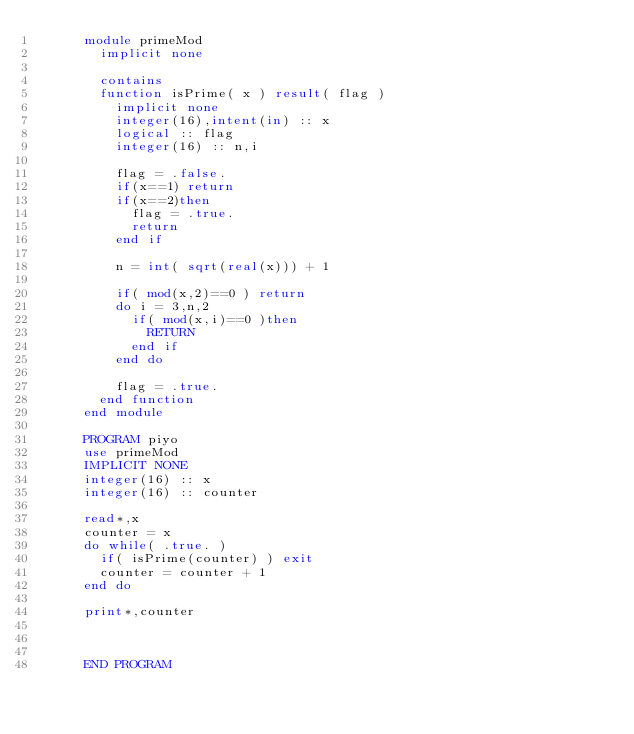Convert code to text. <code><loc_0><loc_0><loc_500><loc_500><_FORTRAN_>      module primeMod
        implicit none
        
        contains
        function isPrime( x ) result( flag )
          implicit none
          integer(16),intent(in) :: x
          logical :: flag
          integer(16) :: n,i
          
          flag = .false.
          if(x==1) return
          if(x==2)then
            flag = .true.
            return
          end if
          
          n = int( sqrt(real(x))) + 1
          
          if( mod(x,2)==0 ) return
          do i = 3,n,2
            if( mod(x,i)==0 )then
              RETURN
            end if
          end do
          
          flag = .true.
        end function
      end module
      
      PROGRAM piyo
      use primeMod
      IMPLICIT NONE
      integer(16) :: x
      integer(16) :: counter
      
      read*,x
      counter = x
      do while( .true. )
        if( isPrime(counter) ) exit
        counter = counter + 1
      end do
      
      print*,counter
      
      
      
      END PROGRAM</code> 